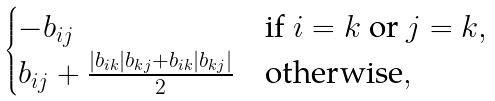<formula> <loc_0><loc_0><loc_500><loc_500>\begin{cases} - b _ { i j } & \text {if $i=k$ or $j=k$} , \\ b _ { i j } + \frac { | b _ { i k } | b _ { k j } + b _ { i k } | b _ { k j } | } { 2 } & \text {otherwise} , \end{cases}</formula> 